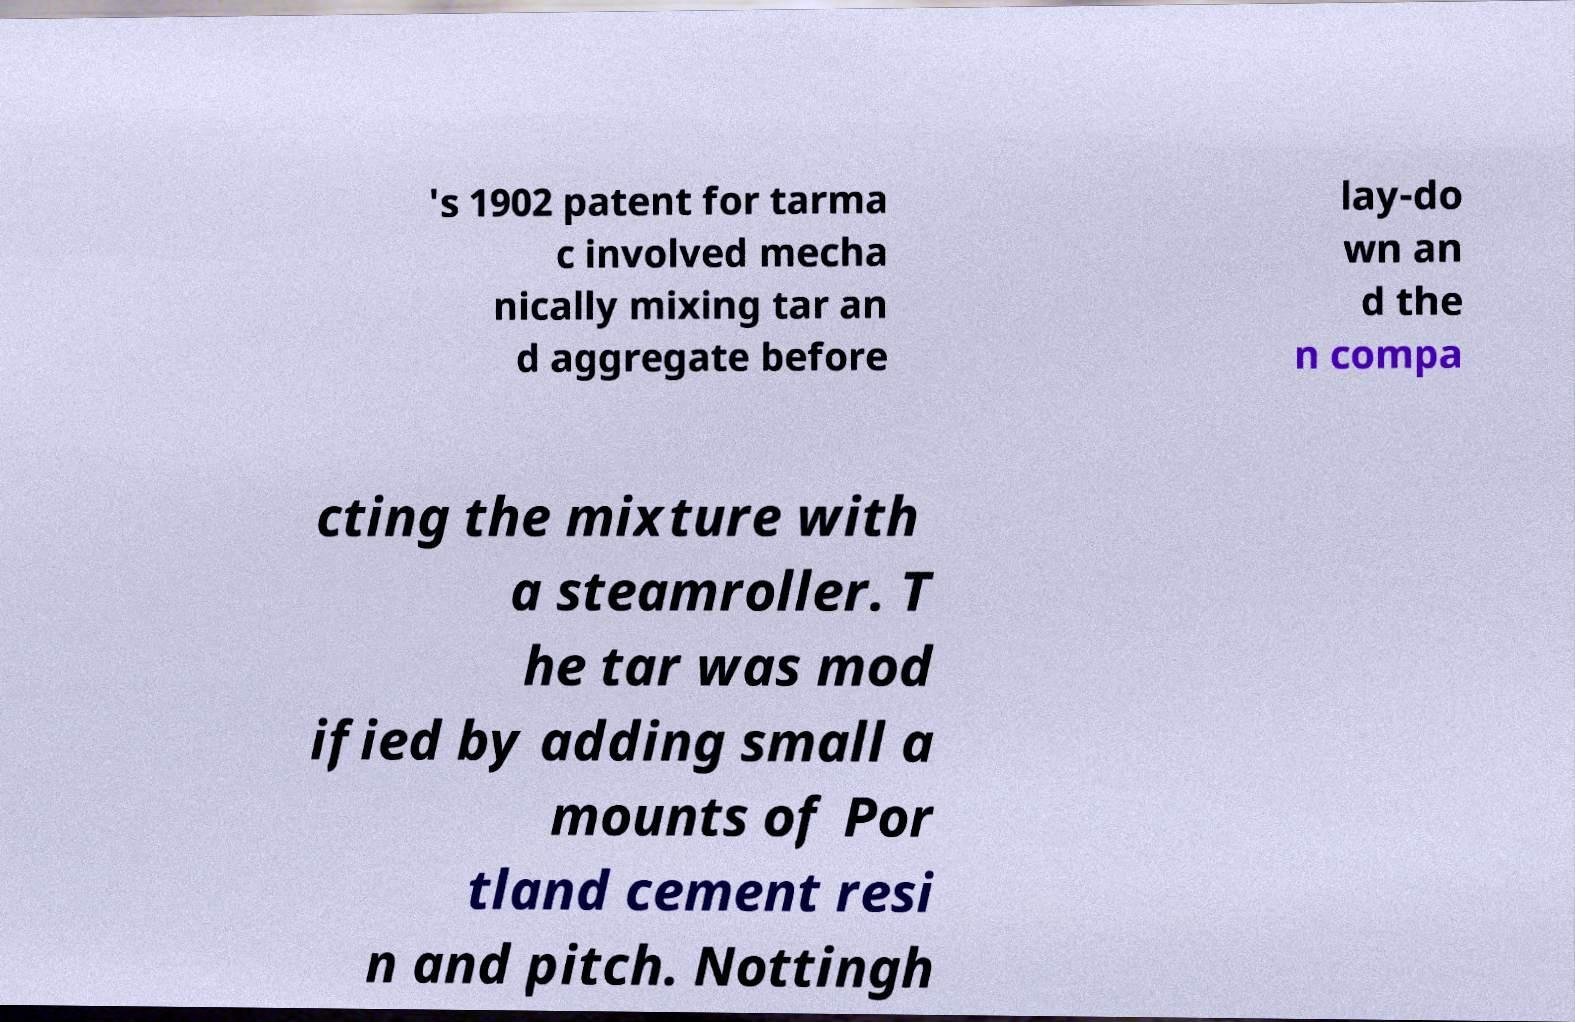Can you read and provide the text displayed in the image?This photo seems to have some interesting text. Can you extract and type it out for me? 's 1902 patent for tarma c involved mecha nically mixing tar an d aggregate before lay-do wn an d the n compa cting the mixture with a steamroller. T he tar was mod ified by adding small a mounts of Por tland cement resi n and pitch. Nottingh 